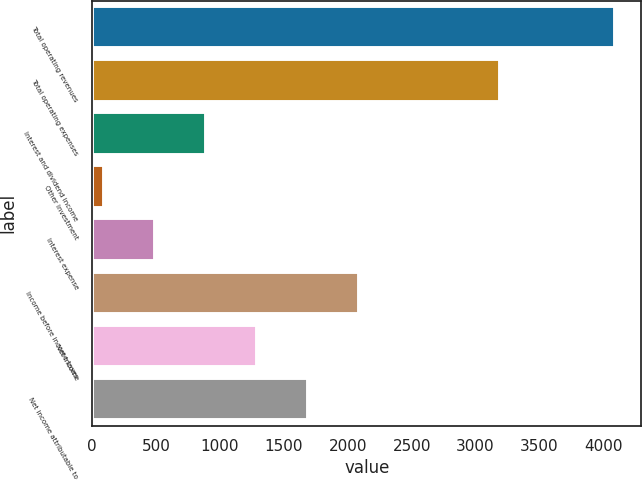<chart> <loc_0><loc_0><loc_500><loc_500><bar_chart><fcel>Total operating revenues<fcel>Total operating expenses<fcel>Interest and dividend income<fcel>Other investment<fcel>Interest expense<fcel>Income before income taxes<fcel>Net income<fcel>Net income attributable to<nl><fcel>4092.2<fcel>3194.1<fcel>890.36<fcel>89.9<fcel>490.13<fcel>2091.05<fcel>1290.59<fcel>1690.82<nl></chart> 